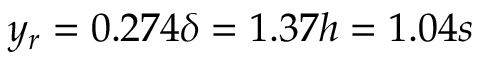<formula> <loc_0><loc_0><loc_500><loc_500>y _ { r } = 0 . 2 7 4 \delta = 1 . 3 7 h = 1 . 0 4 s</formula> 